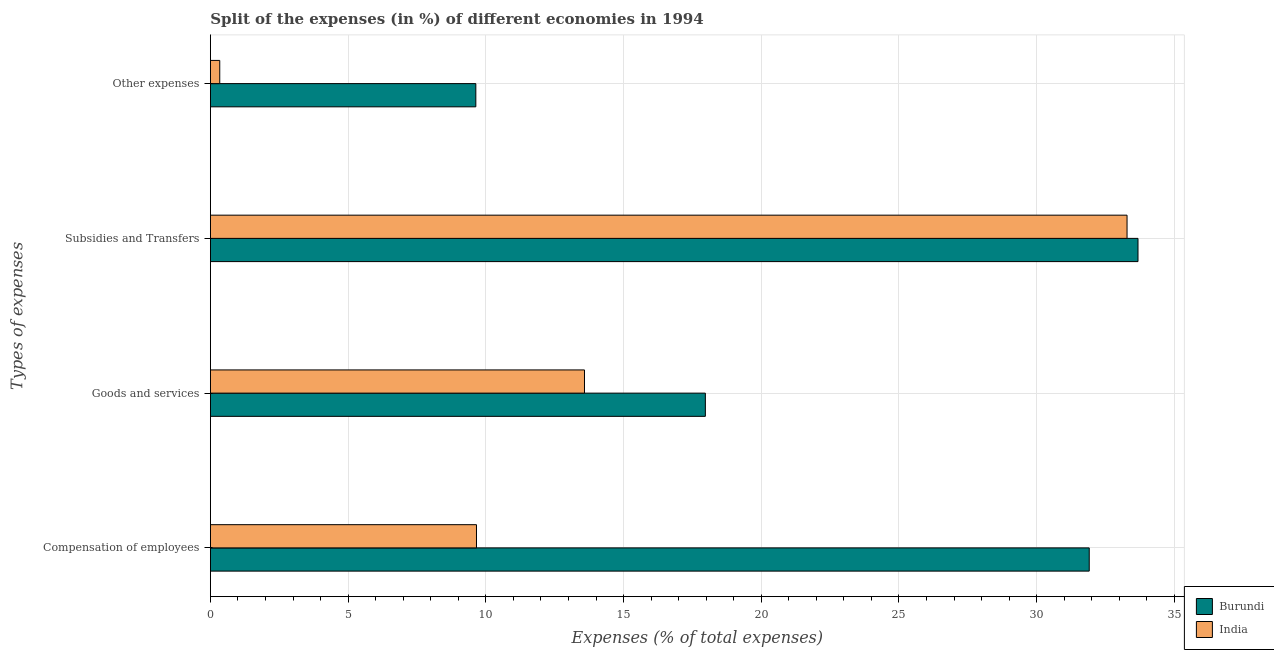How many groups of bars are there?
Offer a terse response. 4. Are the number of bars per tick equal to the number of legend labels?
Ensure brevity in your answer.  Yes. How many bars are there on the 2nd tick from the top?
Keep it short and to the point. 2. How many bars are there on the 2nd tick from the bottom?
Your response must be concise. 2. What is the label of the 4th group of bars from the top?
Provide a succinct answer. Compensation of employees. What is the percentage of amount spent on compensation of employees in Burundi?
Give a very brief answer. 31.91. Across all countries, what is the maximum percentage of amount spent on compensation of employees?
Offer a very short reply. 31.91. Across all countries, what is the minimum percentage of amount spent on subsidies?
Provide a short and direct response. 33.28. In which country was the percentage of amount spent on other expenses maximum?
Offer a very short reply. Burundi. What is the total percentage of amount spent on compensation of employees in the graph?
Provide a short and direct response. 41.57. What is the difference between the percentage of amount spent on compensation of employees in Burundi and that in India?
Offer a very short reply. 22.25. What is the difference between the percentage of amount spent on other expenses in India and the percentage of amount spent on compensation of employees in Burundi?
Keep it short and to the point. -31.57. What is the average percentage of amount spent on goods and services per country?
Ensure brevity in your answer.  15.78. What is the difference between the percentage of amount spent on goods and services and percentage of amount spent on subsidies in Burundi?
Your answer should be very brief. -15.71. What is the ratio of the percentage of amount spent on compensation of employees in Burundi to that in India?
Provide a short and direct response. 3.3. Is the percentage of amount spent on other expenses in India less than that in Burundi?
Give a very brief answer. Yes. What is the difference between the highest and the second highest percentage of amount spent on subsidies?
Your answer should be very brief. 0.4. What is the difference between the highest and the lowest percentage of amount spent on goods and services?
Offer a very short reply. 4.39. Is the sum of the percentage of amount spent on other expenses in Burundi and India greater than the maximum percentage of amount spent on goods and services across all countries?
Provide a succinct answer. No. Is it the case that in every country, the sum of the percentage of amount spent on subsidies and percentage of amount spent on goods and services is greater than the sum of percentage of amount spent on other expenses and percentage of amount spent on compensation of employees?
Your response must be concise. Yes. What does the 1st bar from the top in Goods and services represents?
Ensure brevity in your answer.  India. What does the 1st bar from the bottom in Other expenses represents?
Offer a very short reply. Burundi. How many bars are there?
Your answer should be very brief. 8. How many countries are there in the graph?
Offer a very short reply. 2. Are the values on the major ticks of X-axis written in scientific E-notation?
Give a very brief answer. No. Does the graph contain any zero values?
Your answer should be very brief. No. What is the title of the graph?
Give a very brief answer. Split of the expenses (in %) of different economies in 1994. What is the label or title of the X-axis?
Your answer should be very brief. Expenses (% of total expenses). What is the label or title of the Y-axis?
Your answer should be very brief. Types of expenses. What is the Expenses (% of total expenses) in Burundi in Compensation of employees?
Your response must be concise. 31.91. What is the Expenses (% of total expenses) in India in Compensation of employees?
Keep it short and to the point. 9.66. What is the Expenses (% of total expenses) in Burundi in Goods and services?
Offer a terse response. 17.97. What is the Expenses (% of total expenses) of India in Goods and services?
Offer a very short reply. 13.58. What is the Expenses (% of total expenses) in Burundi in Subsidies and Transfers?
Make the answer very short. 33.68. What is the Expenses (% of total expenses) in India in Subsidies and Transfers?
Keep it short and to the point. 33.28. What is the Expenses (% of total expenses) of Burundi in Other expenses?
Your response must be concise. 9.64. What is the Expenses (% of total expenses) in India in Other expenses?
Provide a succinct answer. 0.34. Across all Types of expenses, what is the maximum Expenses (% of total expenses) in Burundi?
Provide a short and direct response. 33.68. Across all Types of expenses, what is the maximum Expenses (% of total expenses) in India?
Offer a very short reply. 33.28. Across all Types of expenses, what is the minimum Expenses (% of total expenses) in Burundi?
Offer a very short reply. 9.64. Across all Types of expenses, what is the minimum Expenses (% of total expenses) in India?
Provide a succinct answer. 0.34. What is the total Expenses (% of total expenses) in Burundi in the graph?
Provide a short and direct response. 93.19. What is the total Expenses (% of total expenses) of India in the graph?
Give a very brief answer. 56.86. What is the difference between the Expenses (% of total expenses) of Burundi in Compensation of employees and that in Goods and services?
Your answer should be compact. 13.94. What is the difference between the Expenses (% of total expenses) of India in Compensation of employees and that in Goods and services?
Provide a short and direct response. -3.92. What is the difference between the Expenses (% of total expenses) in Burundi in Compensation of employees and that in Subsidies and Transfers?
Offer a very short reply. -1.77. What is the difference between the Expenses (% of total expenses) in India in Compensation of employees and that in Subsidies and Transfers?
Offer a very short reply. -23.62. What is the difference between the Expenses (% of total expenses) in Burundi in Compensation of employees and that in Other expenses?
Offer a terse response. 22.27. What is the difference between the Expenses (% of total expenses) of India in Compensation of employees and that in Other expenses?
Your answer should be compact. 9.32. What is the difference between the Expenses (% of total expenses) of Burundi in Goods and services and that in Subsidies and Transfers?
Your answer should be very brief. -15.71. What is the difference between the Expenses (% of total expenses) of India in Goods and services and that in Subsidies and Transfers?
Ensure brevity in your answer.  -19.7. What is the difference between the Expenses (% of total expenses) of Burundi in Goods and services and that in Other expenses?
Your answer should be compact. 8.33. What is the difference between the Expenses (% of total expenses) of India in Goods and services and that in Other expenses?
Provide a short and direct response. 13.24. What is the difference between the Expenses (% of total expenses) in Burundi in Subsidies and Transfers and that in Other expenses?
Your answer should be compact. 24.04. What is the difference between the Expenses (% of total expenses) of India in Subsidies and Transfers and that in Other expenses?
Keep it short and to the point. 32.94. What is the difference between the Expenses (% of total expenses) in Burundi in Compensation of employees and the Expenses (% of total expenses) in India in Goods and services?
Make the answer very short. 18.33. What is the difference between the Expenses (% of total expenses) of Burundi in Compensation of employees and the Expenses (% of total expenses) of India in Subsidies and Transfers?
Make the answer very short. -1.37. What is the difference between the Expenses (% of total expenses) in Burundi in Compensation of employees and the Expenses (% of total expenses) in India in Other expenses?
Provide a succinct answer. 31.57. What is the difference between the Expenses (% of total expenses) in Burundi in Goods and services and the Expenses (% of total expenses) in India in Subsidies and Transfers?
Your answer should be compact. -15.31. What is the difference between the Expenses (% of total expenses) of Burundi in Goods and services and the Expenses (% of total expenses) of India in Other expenses?
Keep it short and to the point. 17.63. What is the difference between the Expenses (% of total expenses) in Burundi in Subsidies and Transfers and the Expenses (% of total expenses) in India in Other expenses?
Your answer should be compact. 33.34. What is the average Expenses (% of total expenses) of Burundi per Types of expenses?
Ensure brevity in your answer.  23.3. What is the average Expenses (% of total expenses) in India per Types of expenses?
Provide a short and direct response. 14.22. What is the difference between the Expenses (% of total expenses) of Burundi and Expenses (% of total expenses) of India in Compensation of employees?
Provide a short and direct response. 22.25. What is the difference between the Expenses (% of total expenses) of Burundi and Expenses (% of total expenses) of India in Goods and services?
Your answer should be very brief. 4.39. What is the difference between the Expenses (% of total expenses) of Burundi and Expenses (% of total expenses) of India in Subsidies and Transfers?
Provide a succinct answer. 0.4. What is the difference between the Expenses (% of total expenses) of Burundi and Expenses (% of total expenses) of India in Other expenses?
Offer a very short reply. 9.3. What is the ratio of the Expenses (% of total expenses) of Burundi in Compensation of employees to that in Goods and services?
Make the answer very short. 1.78. What is the ratio of the Expenses (% of total expenses) in India in Compensation of employees to that in Goods and services?
Provide a succinct answer. 0.71. What is the ratio of the Expenses (% of total expenses) in Burundi in Compensation of employees to that in Subsidies and Transfers?
Provide a short and direct response. 0.95. What is the ratio of the Expenses (% of total expenses) in India in Compensation of employees to that in Subsidies and Transfers?
Offer a terse response. 0.29. What is the ratio of the Expenses (% of total expenses) of Burundi in Compensation of employees to that in Other expenses?
Offer a very short reply. 3.31. What is the ratio of the Expenses (% of total expenses) in India in Compensation of employees to that in Other expenses?
Your response must be concise. 28.43. What is the ratio of the Expenses (% of total expenses) in Burundi in Goods and services to that in Subsidies and Transfers?
Offer a very short reply. 0.53. What is the ratio of the Expenses (% of total expenses) in India in Goods and services to that in Subsidies and Transfers?
Offer a terse response. 0.41. What is the ratio of the Expenses (% of total expenses) in Burundi in Goods and services to that in Other expenses?
Your answer should be compact. 1.86. What is the ratio of the Expenses (% of total expenses) of India in Goods and services to that in Other expenses?
Keep it short and to the point. 39.96. What is the ratio of the Expenses (% of total expenses) of Burundi in Subsidies and Transfers to that in Other expenses?
Offer a very short reply. 3.49. What is the ratio of the Expenses (% of total expenses) in India in Subsidies and Transfers to that in Other expenses?
Offer a terse response. 97.92. What is the difference between the highest and the second highest Expenses (% of total expenses) in Burundi?
Provide a succinct answer. 1.77. What is the difference between the highest and the second highest Expenses (% of total expenses) of India?
Provide a succinct answer. 19.7. What is the difference between the highest and the lowest Expenses (% of total expenses) in Burundi?
Make the answer very short. 24.04. What is the difference between the highest and the lowest Expenses (% of total expenses) in India?
Make the answer very short. 32.94. 